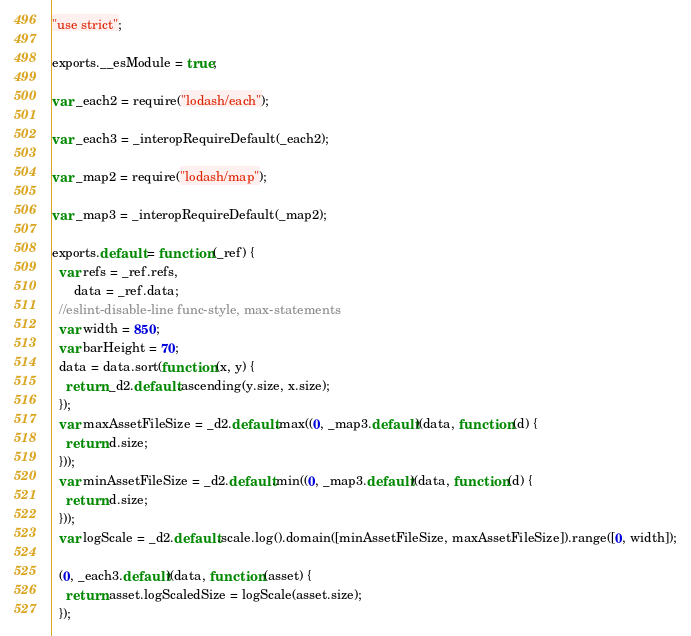<code> <loc_0><loc_0><loc_500><loc_500><_JavaScript_>"use strict";

exports.__esModule = true;

var _each2 = require("lodash/each");

var _each3 = _interopRequireDefault(_each2);

var _map2 = require("lodash/map");

var _map3 = _interopRequireDefault(_map2);

exports.default = function (_ref) {
  var refs = _ref.refs,
      data = _ref.data;
  //eslint-disable-line func-style, max-statements
  var width = 850;
  var barHeight = 70;
  data = data.sort(function (x, y) {
    return _d2.default.ascending(y.size, x.size);
  });
  var maxAssetFileSize = _d2.default.max((0, _map3.default)(data, function (d) {
    return d.size;
  }));
  var minAssetFileSize = _d2.default.min((0, _map3.default)(data, function (d) {
    return d.size;
  }));
  var logScale = _d2.default.scale.log().domain([minAssetFileSize, maxAssetFileSize]).range([0, width]);

  (0, _each3.default)(data, function (asset) {
    return asset.logScaledSize = logScale(asset.size);
  });
</code> 